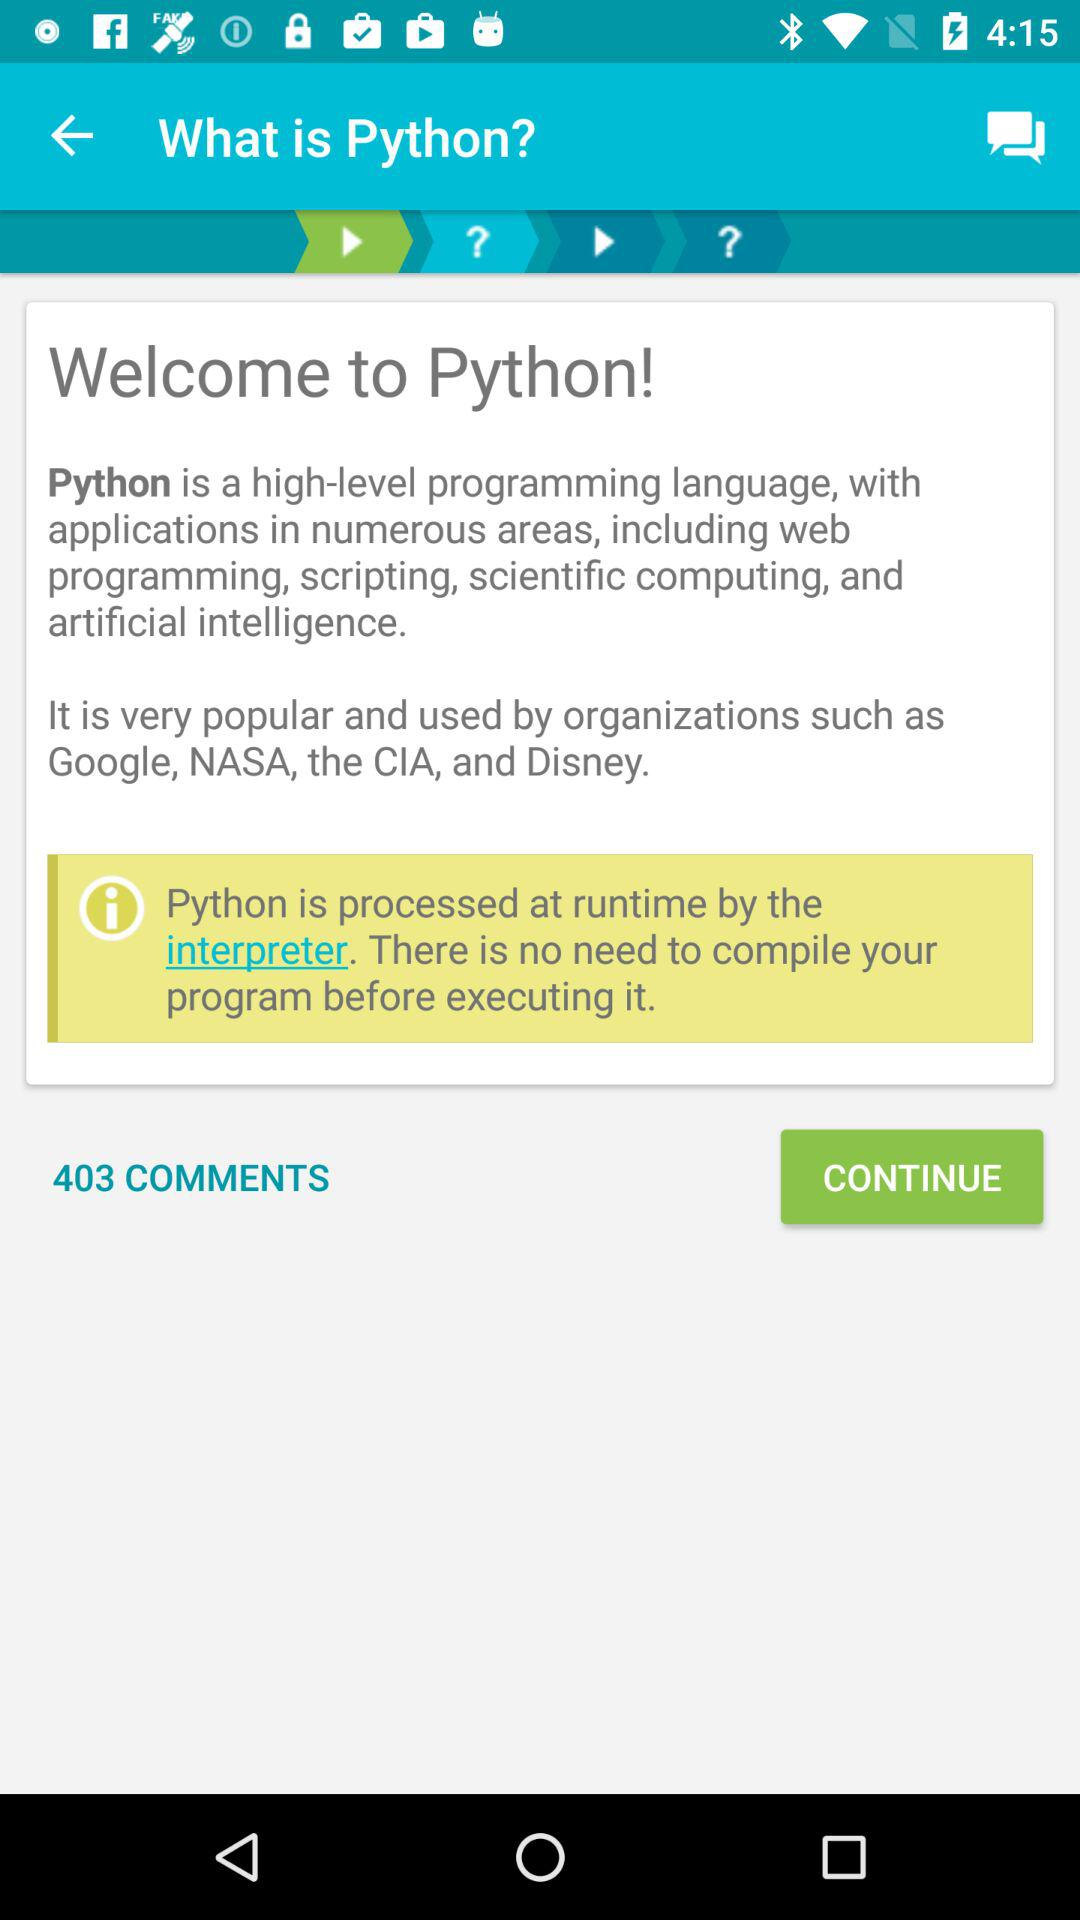How many comments are there on the question? There are 403 comments. 